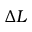Convert formula to latex. <formula><loc_0><loc_0><loc_500><loc_500>\Delta L</formula> 